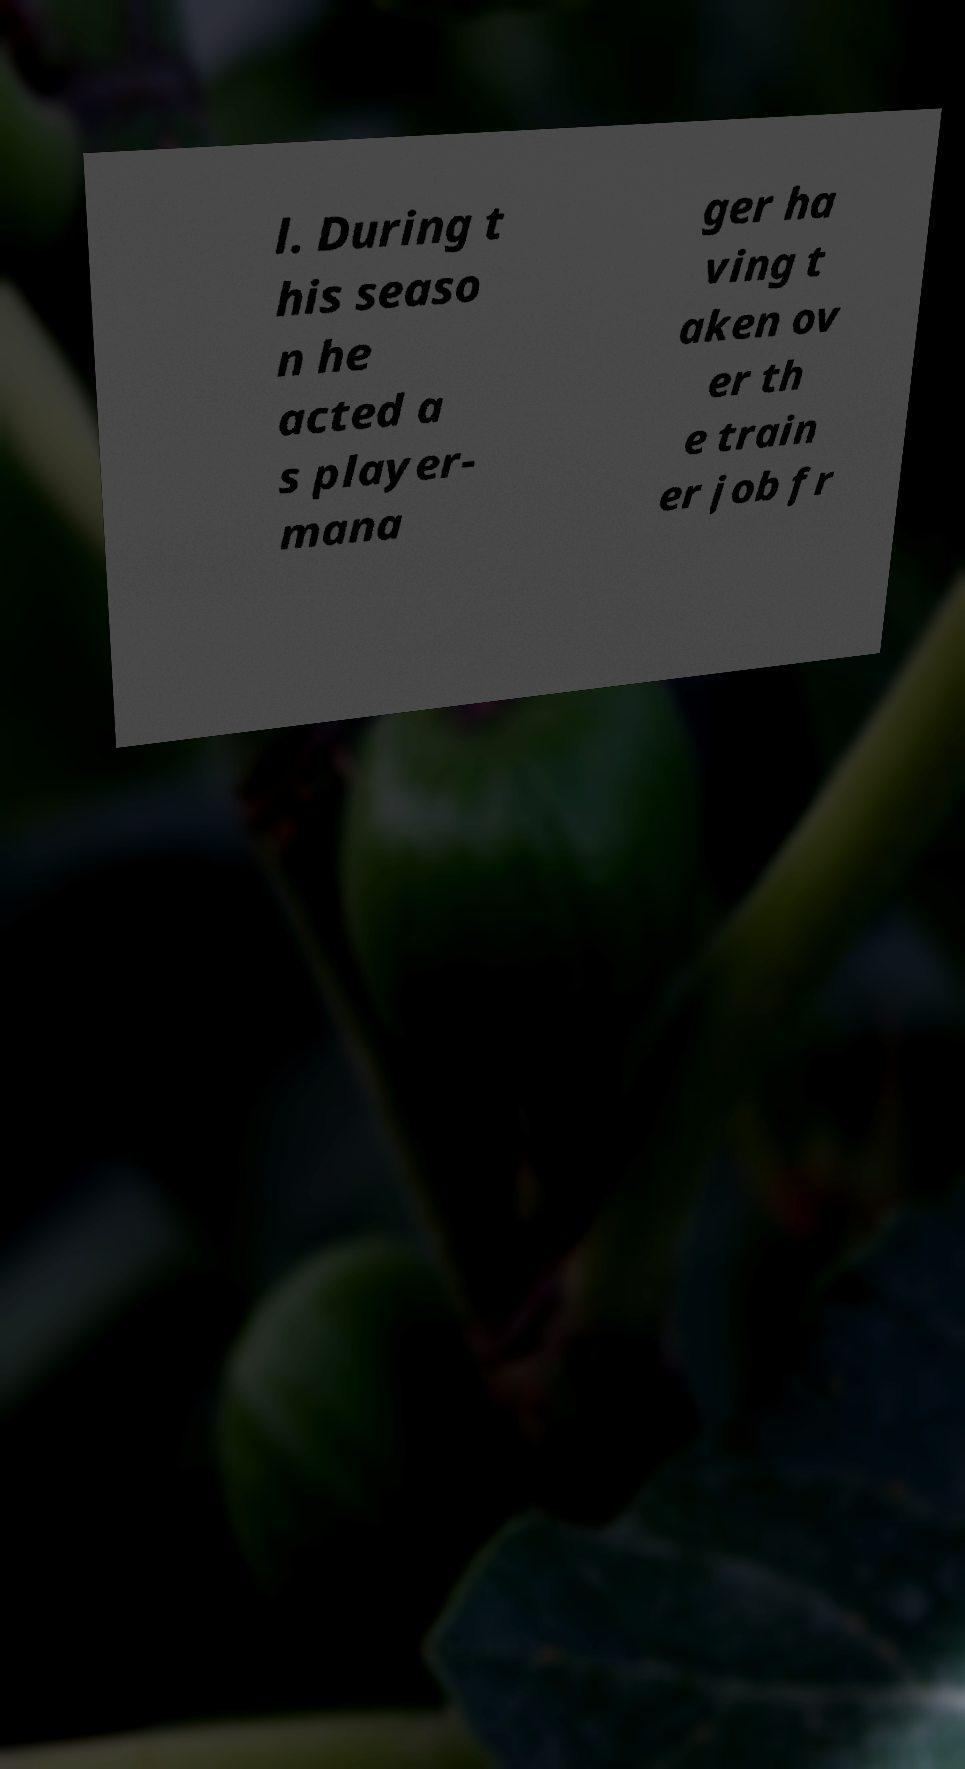Please identify and transcribe the text found in this image. l. During t his seaso n he acted a s player- mana ger ha ving t aken ov er th e train er job fr 